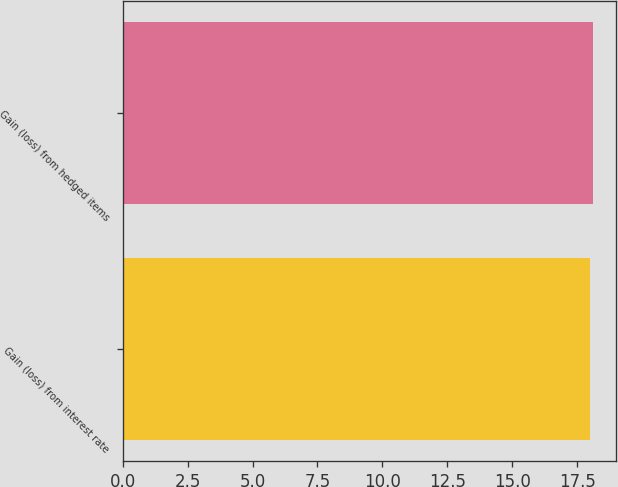<chart> <loc_0><loc_0><loc_500><loc_500><bar_chart><fcel>Gain (loss) from interest rate<fcel>Gain (loss) from hedged items<nl><fcel>18<fcel>18.1<nl></chart> 